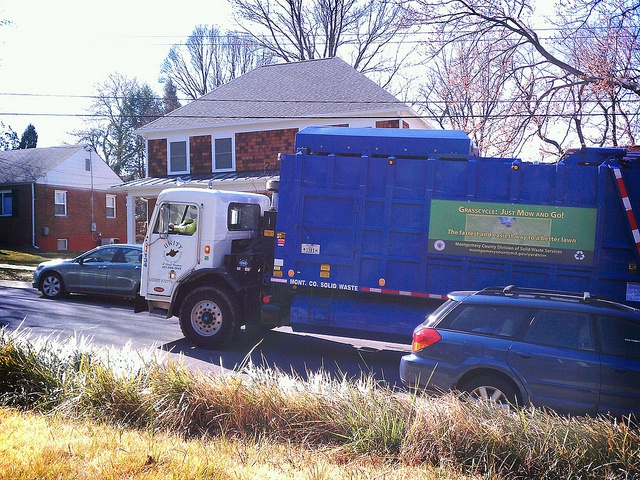Describe the objects in this image and their specific colors. I can see truck in ivory, darkblue, navy, blue, and black tones, car in ivory, navy, black, darkblue, and purple tones, car in ivory, navy, black, gray, and darkblue tones, and people in ivory, gray, darkgray, black, and white tones in this image. 